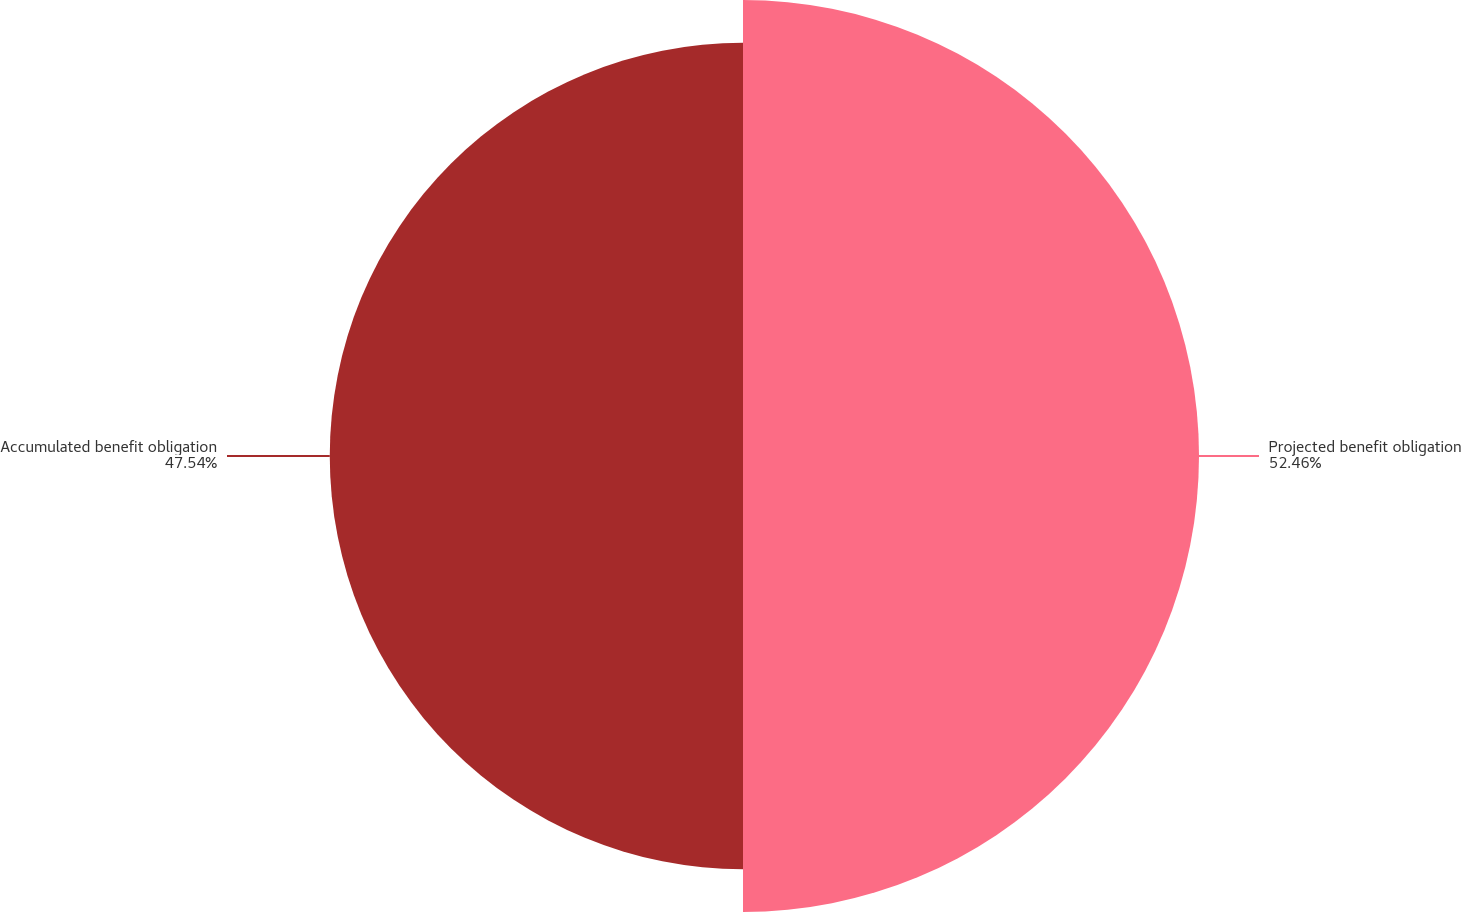<chart> <loc_0><loc_0><loc_500><loc_500><pie_chart><fcel>Projected benefit obligation<fcel>Accumulated benefit obligation<nl><fcel>52.46%<fcel>47.54%<nl></chart> 